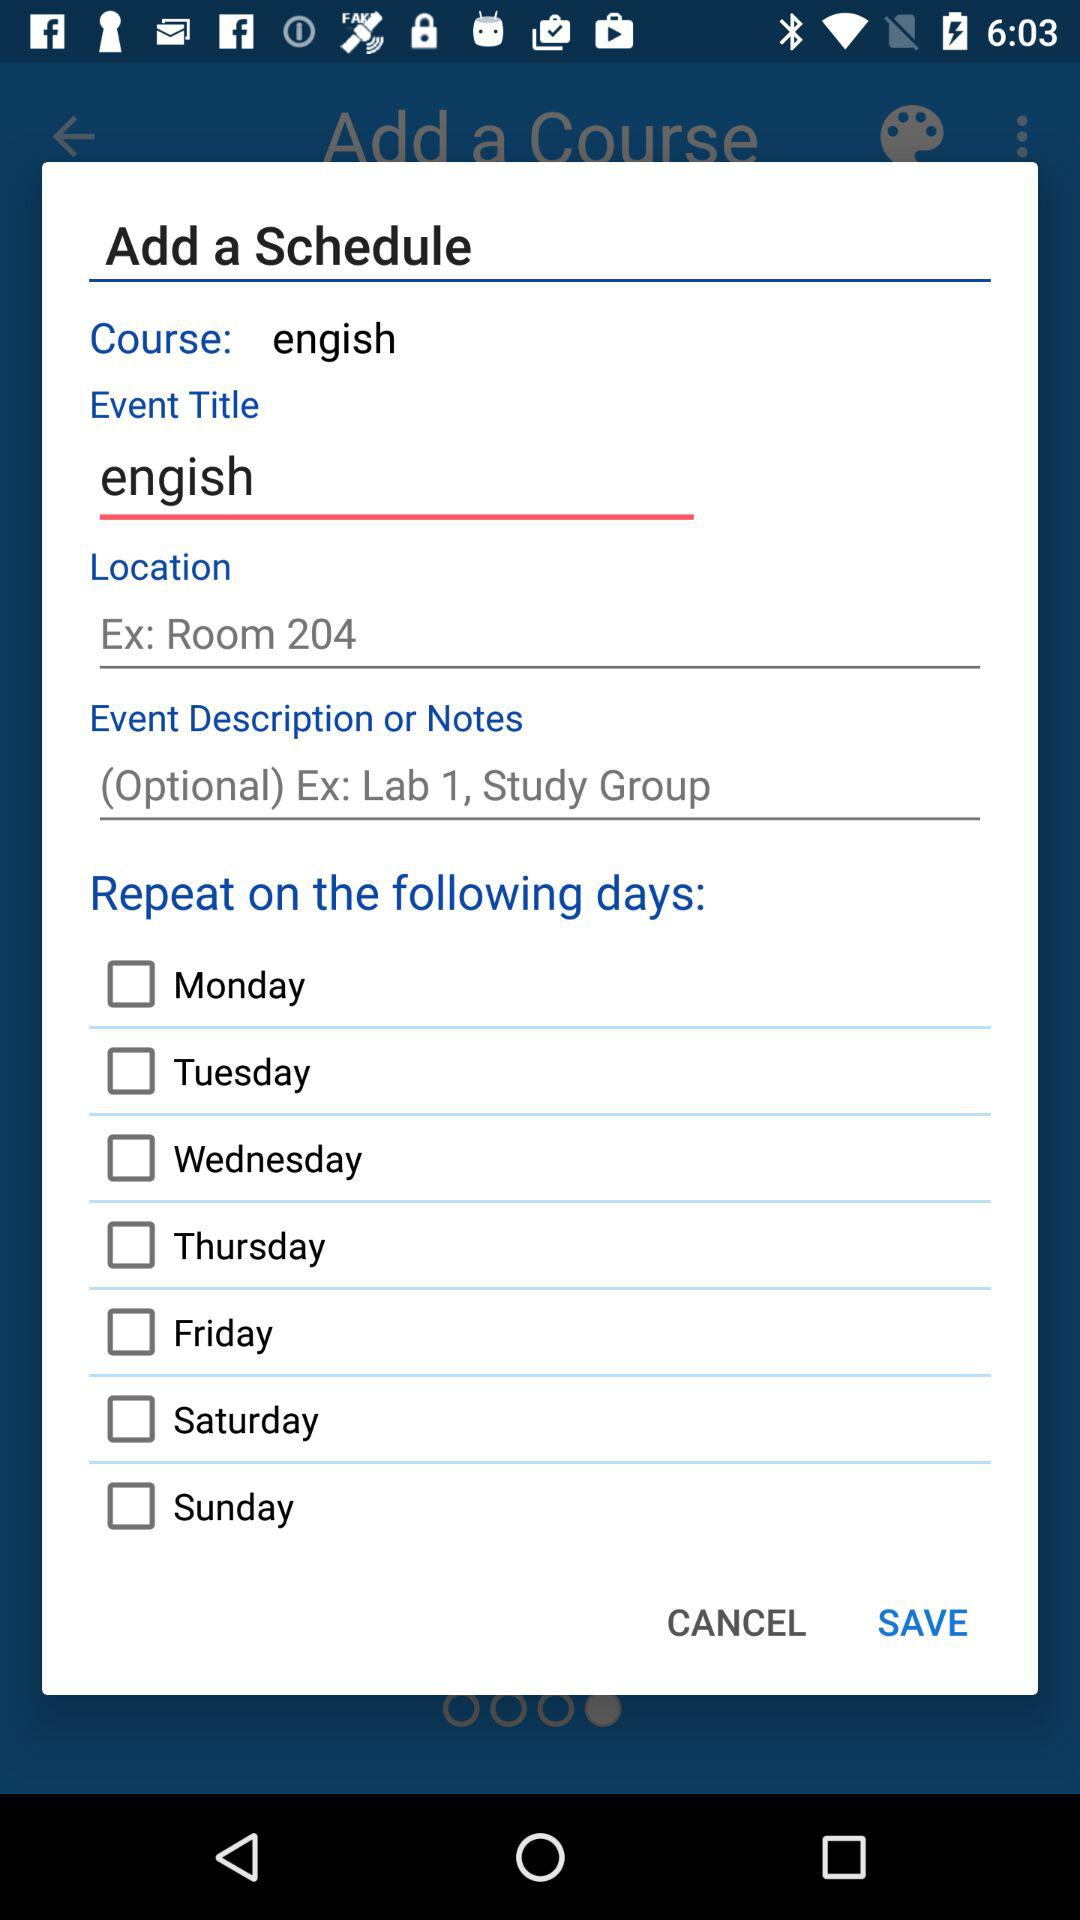What is the "Event Description or Notes"? The "Event Description or Notes" is "(Optional) Ex: Lab 1, Study Group". 